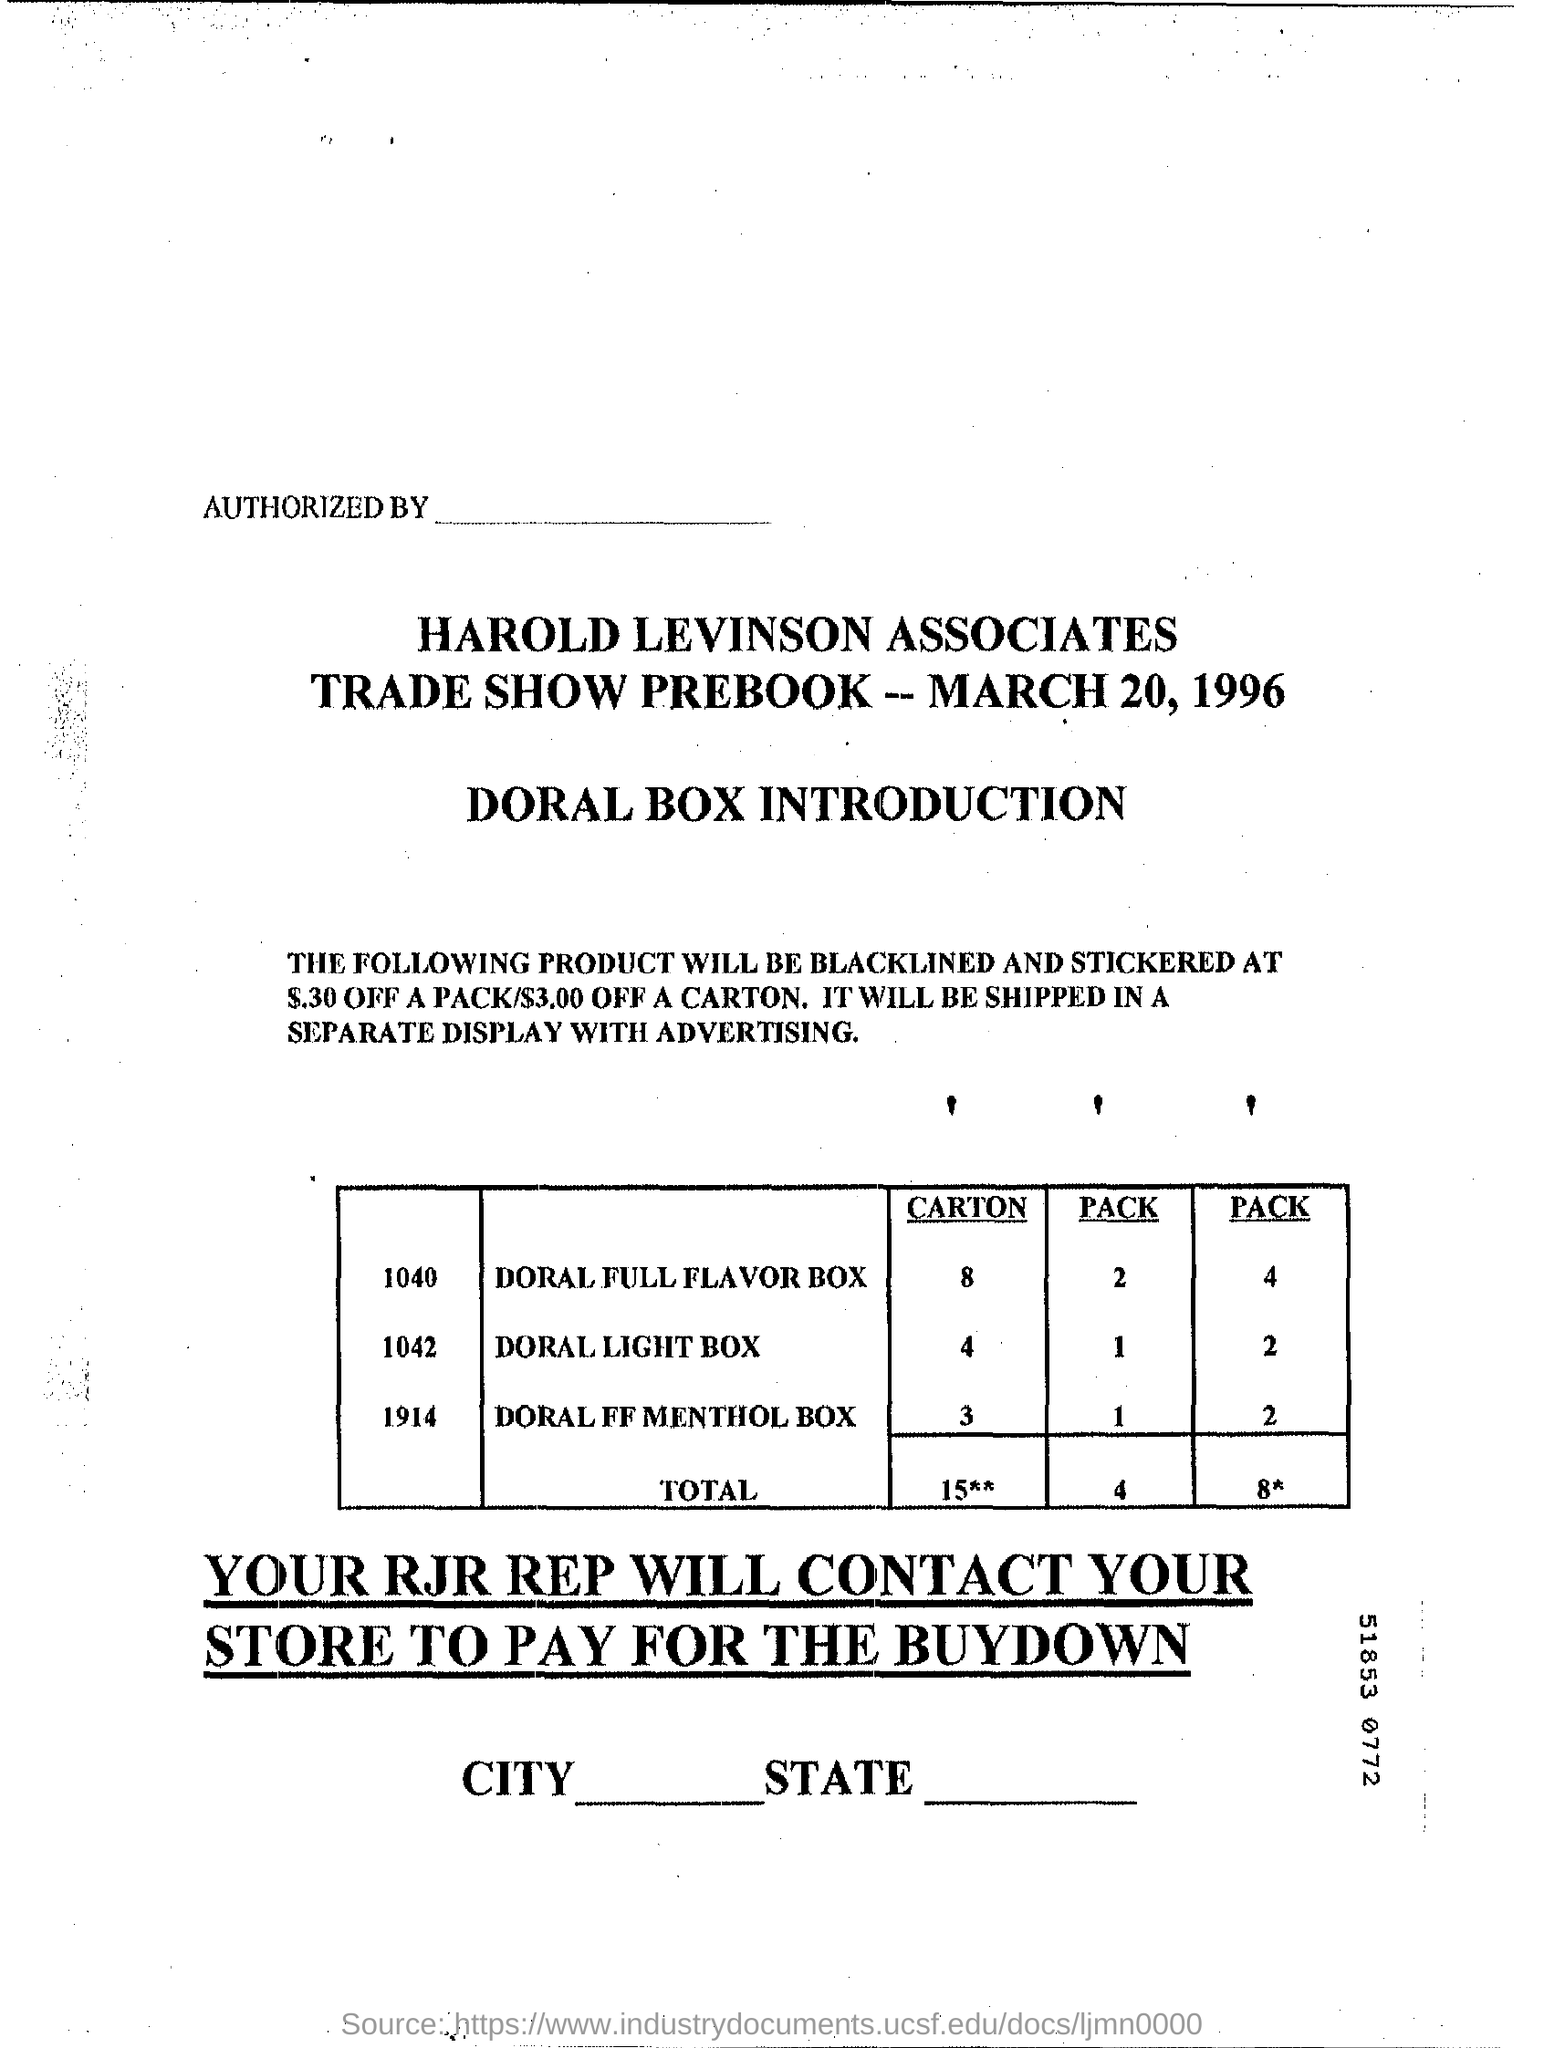What is the date on the document?
Your answer should be very brief. March 20, 1996. How many "CARTON" of "Doral Light Box"?
Ensure brevity in your answer.  2. 